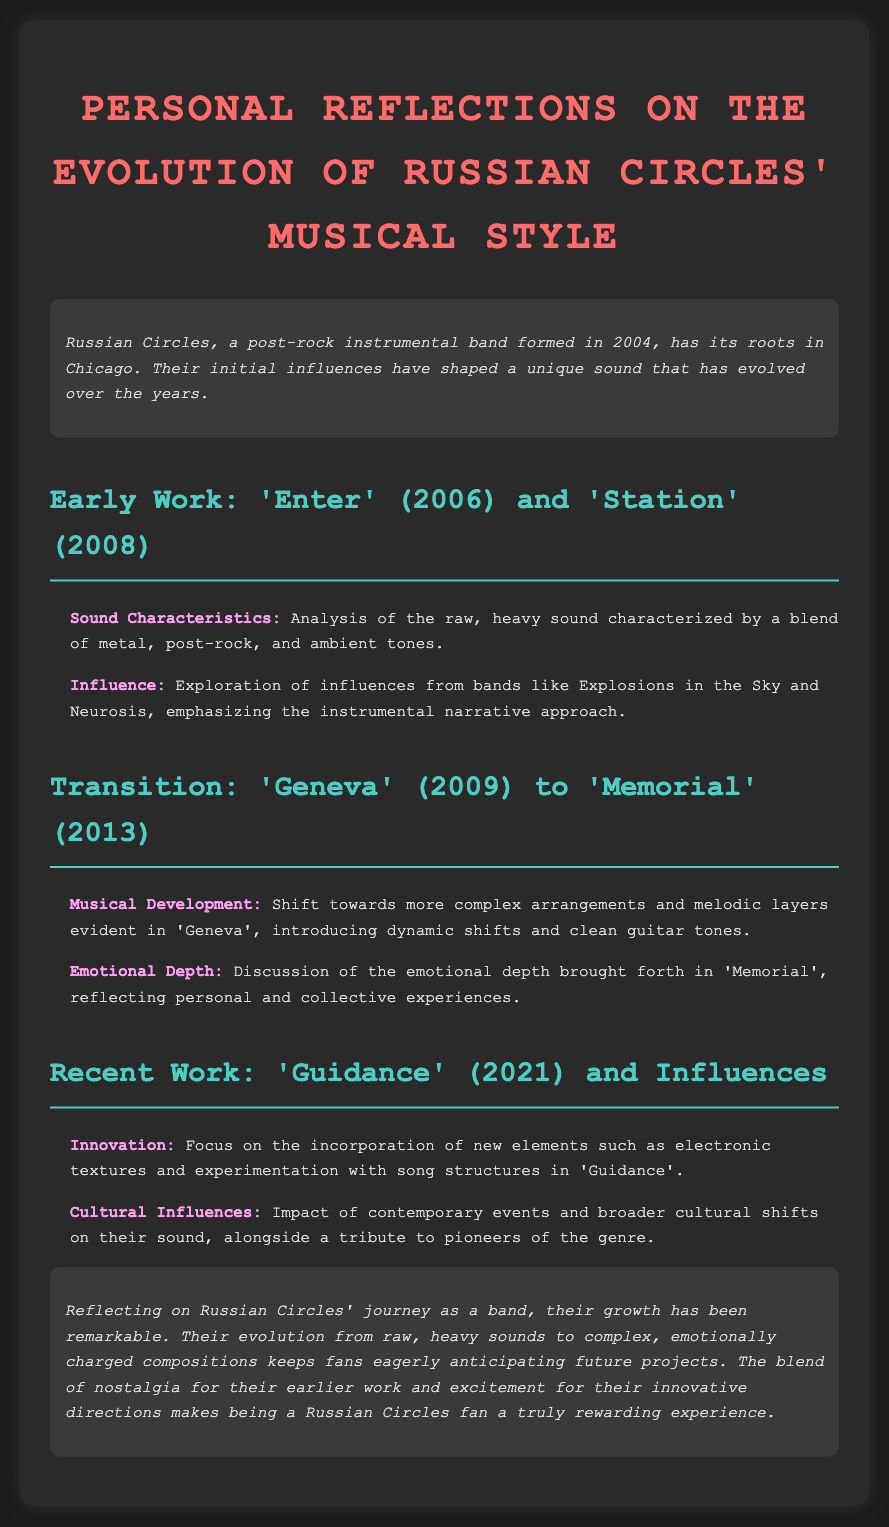What year was 'Enter' released? 'Enter' was released in 2006, as mentioned in the document.
Answer: 2006 What style shift is evident in 'Geneva'? The document states there is a shift towards more complex arrangements and melodic layers in 'Geneva'.
Answer: Complex arrangements Which band's influence is noted in their early work? The document mentions Explosions in the Sky as an influence on their early sound.
Answer: Explosions in the Sky What was a prominent feature of 'Guidance'? 'Guidance' incorporated new elements such as electronic textures, as per the document.
Answer: Electronic textures How many albums are discussed in the transition from 'Geneva' to 'Memorial'? The discussion focuses on the transition between 'Geneva' and 'Memorial', which is two albums.
Answer: Two What emotional aspect is highlighted in 'Memorial'? The document highlights emotional depth in 'Memorial' reflecting personal and collective experiences.
Answer: Emotional depth What is a notable quality of Russian Circles' growth? The document reflects that their evolution has been remarkable from their earlier work to complex compositions.
Answer: Remarkable What cultural aspect influenced their latest sound? The document indicates that contemporary events and broader cultural shifts impacted their recent music style.
Answer: Contemporary events 